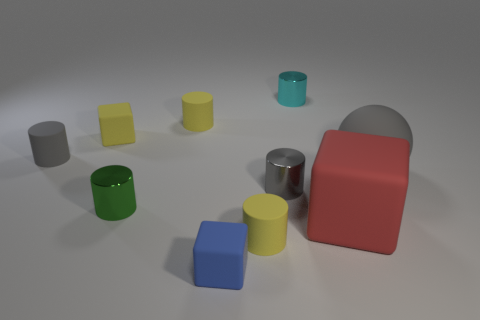Are there any blue rubber cylinders?
Offer a very short reply. No. Are the tiny yellow cylinder behind the big ball and the cube that is to the right of the blue rubber thing made of the same material?
Keep it short and to the point. Yes. The rubber thing that is the same color as the big rubber sphere is what shape?
Your answer should be very brief. Cylinder. What number of objects are things behind the large matte ball or gray objects that are on the right side of the green shiny cylinder?
Provide a succinct answer. 6. There is a rubber cylinder that is on the right side of the tiny blue object; does it have the same color as the tiny rubber cube that is behind the small gray metallic object?
Keep it short and to the point. Yes. There is a thing that is on the right side of the tiny gray metallic thing and in front of the small green cylinder; what is its shape?
Offer a terse response. Cube. The sphere that is the same size as the red thing is what color?
Make the answer very short. Gray. Are there any shiny cylinders that have the same color as the large sphere?
Provide a succinct answer. Yes. Do the rubber cylinder in front of the green metal cylinder and the cube behind the small green metal object have the same size?
Offer a terse response. Yes. The tiny thing that is both in front of the small gray rubber cylinder and behind the green cylinder is made of what material?
Make the answer very short. Metal. 